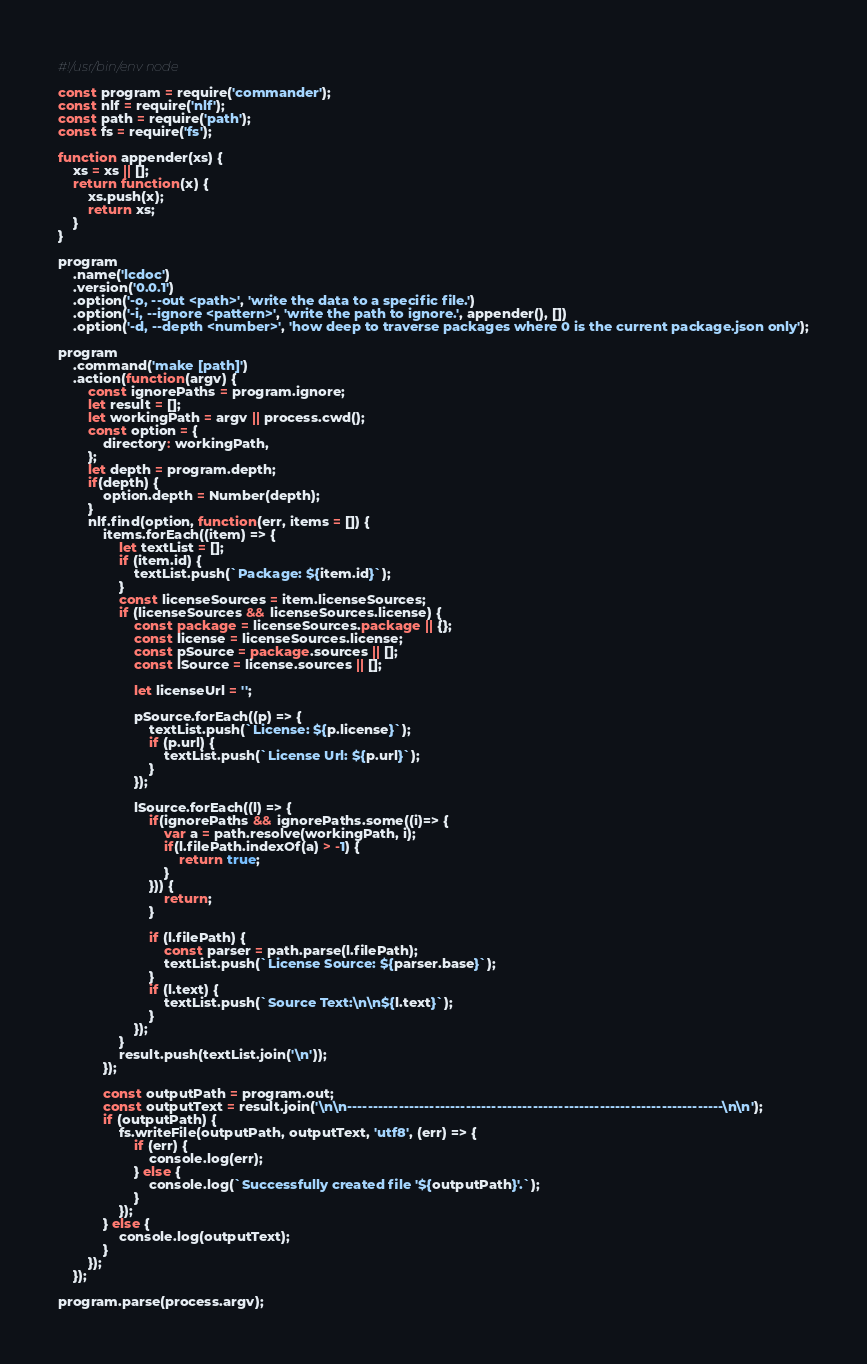Convert code to text. <code><loc_0><loc_0><loc_500><loc_500><_JavaScript_>#!/usr/bin/env node

const program = require('commander');
const nlf = require('nlf');
const path = require('path');
const fs = require('fs');

function appender(xs) {
    xs = xs || [];
    return function(x) {
        xs.push(x);
        return xs;
    }
}

program
    .name('lcdoc')
    .version('0.0.1')
    .option('-o, --out <path>', 'write the data to a specific file.')
    .option('-i, --ignore <pattern>', 'write the path to ignore.', appender(), [])
    .option('-d, --depth <number>', 'how deep to traverse packages where 0 is the current package.json only');

program
    .command('make [path]')
    .action(function(argv) {
        const ignorePaths = program.ignore;
        let result = [];
        let workingPath = argv || process.cwd();
        const option = {
            directory: workingPath,
        };
        let depth = program.depth;
        if(depth) {
            option.depth = Number(depth);
        }
        nlf.find(option, function(err, items = []) {
            items.forEach((item) => {
                let textList = [];
                if (item.id) {
                    textList.push(`Package: ${item.id}`);
                }
                const licenseSources = item.licenseSources;
                if (licenseSources && licenseSources.license) {
                    const package = licenseSources.package || {};
                    const license = licenseSources.license;
                    const pSource = package.sources || [];
                    const lSource = license.sources || [];

                    let licenseUrl = '';

                    pSource.forEach((p) => {
                        textList.push(`License: ${p.license}`);
                        if (p.url) {
                            textList.push(`License Url: ${p.url}`);
                        }
                    });

                    lSource.forEach((l) => {
                        if(ignorePaths && ignorePaths.some((i)=> {
                            var a = path.resolve(workingPath, i);
                            if(l.filePath.indexOf(a) > -1) {
                                return true;
                            }
                        })) {
                            return;
                        }

                        if (l.filePath) {
                            const parser = path.parse(l.filePath);
                            textList.push(`License Source: ${parser.base}`);
                        }
                        if (l.text) {
                            textList.push(`Source Text:\n\n${l.text}`);
                        }
                    });
                }
                result.push(textList.join('\n'));
            });

            const outputPath = program.out;
            const outputText = result.join('\n\n-------------------------------------------------------------------------\n\n');
            if (outputPath) {
                fs.writeFile(outputPath, outputText, 'utf8', (err) => {
                    if (err) {
                        console.log(err);
                    } else {
                        console.log(`Successfully created file '${outputPath}'.`);
                    }
                });
            } else {
                console.log(outputText);
            }
        });
    });

program.parse(process.argv);

</code> 